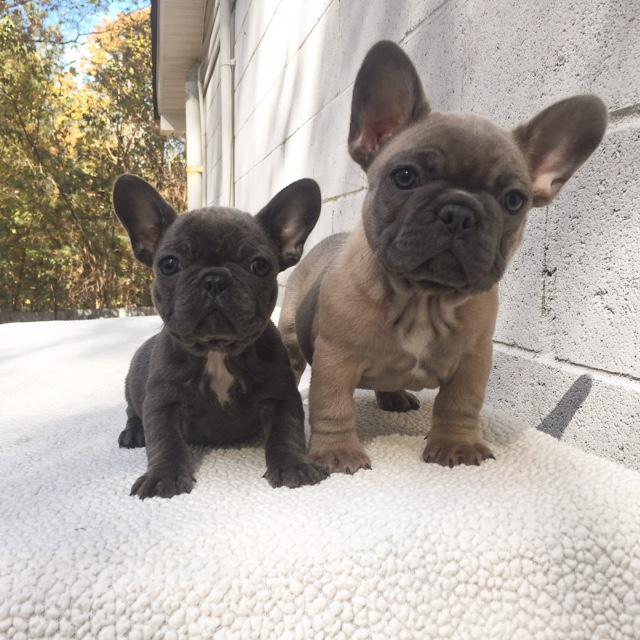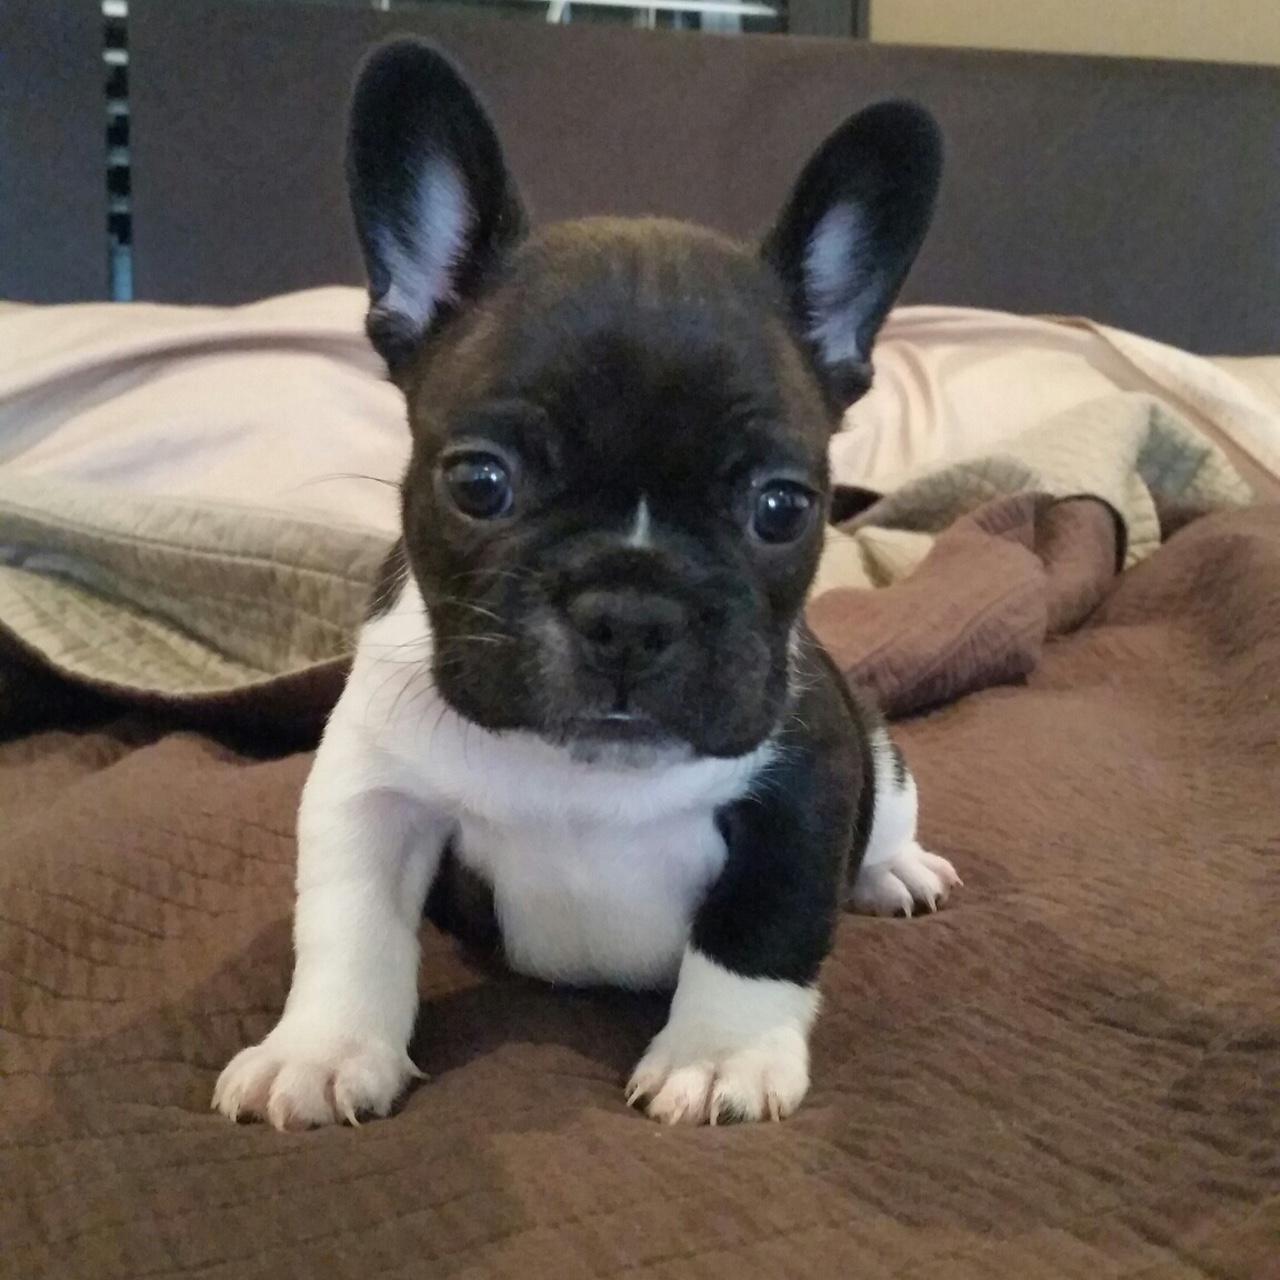The first image is the image on the left, the second image is the image on the right. Evaluate the accuracy of this statement regarding the images: "There are three dogs". Is it true? Answer yes or no. Yes. The first image is the image on the left, the second image is the image on the right. Analyze the images presented: Is the assertion "There are exactly three puppies." valid? Answer yes or no. Yes. 